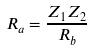<formula> <loc_0><loc_0><loc_500><loc_500>R _ { a } = \frac { Z _ { 1 } Z _ { 2 } } { R _ { b } }</formula> 